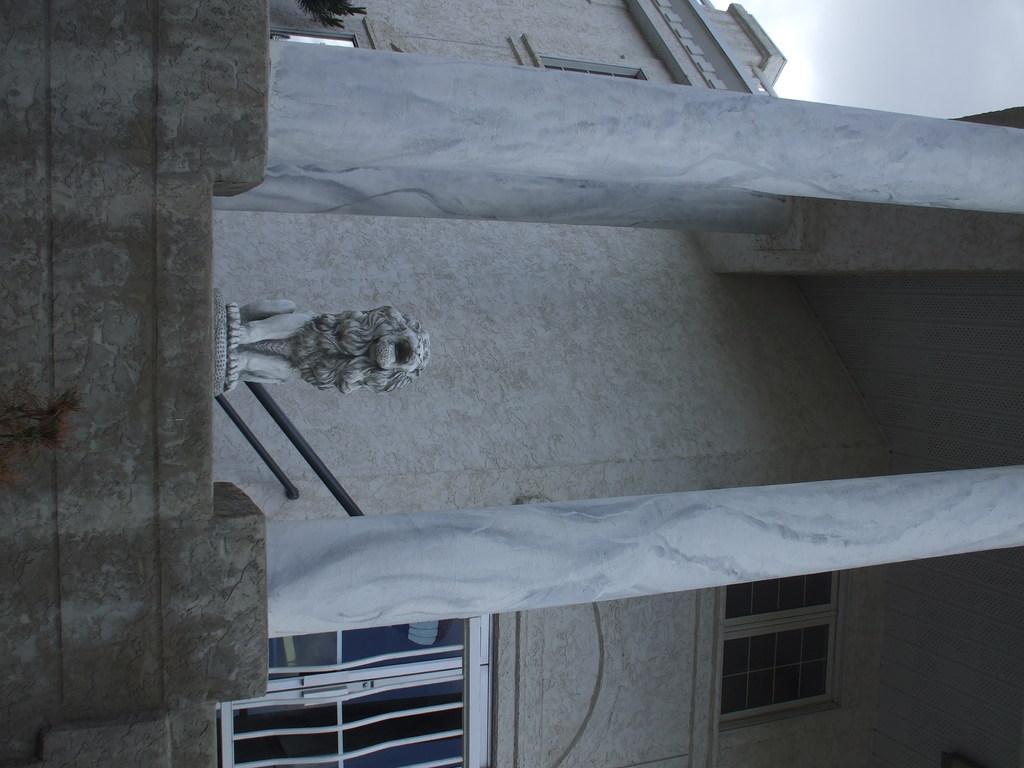Describe this image in one or two sentences. In this picture there is a building and in the foreground there is a statue of a lion on the building and at the back there are windows and there is a hand rail. In the foreground there are two pillars. At the top there is sky and there are clouds. At the bottom there is a plant. 